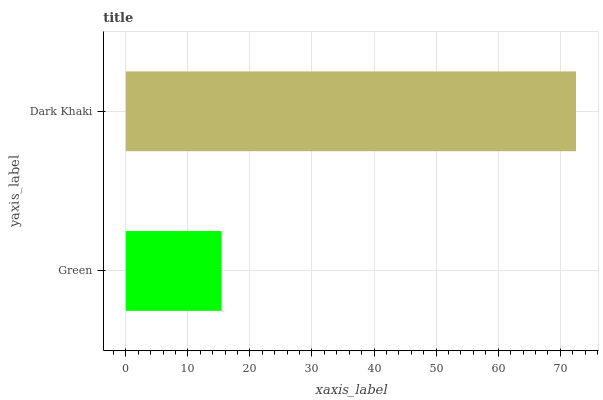Is Green the minimum?
Answer yes or no. Yes. Is Dark Khaki the maximum?
Answer yes or no. Yes. Is Dark Khaki the minimum?
Answer yes or no. No. Is Dark Khaki greater than Green?
Answer yes or no. Yes. Is Green less than Dark Khaki?
Answer yes or no. Yes. Is Green greater than Dark Khaki?
Answer yes or no. No. Is Dark Khaki less than Green?
Answer yes or no. No. Is Dark Khaki the high median?
Answer yes or no. Yes. Is Green the low median?
Answer yes or no. Yes. Is Green the high median?
Answer yes or no. No. Is Dark Khaki the low median?
Answer yes or no. No. 